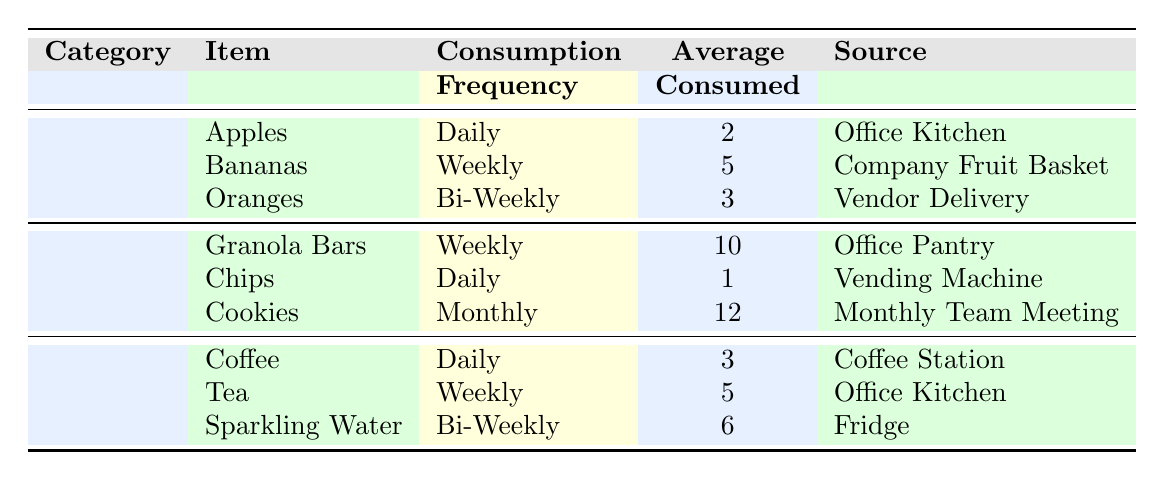What is the average consumption of Coffee? The average consumption of Coffee is listed in the table under the Drinks category. It states that the average consumed is 3.
Answer: 3 How often are Granola Bars consumed? The consumption frequency of Granola Bars is specified in the table as Weekly.
Answer: Weekly Is the consumption of Chips higher than that of Cookies? From the table, Chips are consumed Daily at an average of 1, while Cookies are consumed Monthly at an average of 12. 1 is lesser than 12, so Chips have lower consumption than Cookies.
Answer: No What is the total average consumption of Fruits? To find the total average consumption of Fruits, we will sum the average consumed values: 2 (Apples) + 5 (Bananas) + 3 (Oranges) = 10.
Answer: 10 Which item has the highest average consumption and what is its frequency? In the Snacks category, Granola Bars have the highest average consumption at 10, consumed Weekly.
Answer: Granola Bars, Weekly How many items fall under the Snacks category? The table shows there are three items listed under the Snacks category: Granola Bars, Chips, and Cookies. Therefore, the total count is three.
Answer: 3 Are all the Drinks daily consumables? In the Drinks category, Coffee is consumed Daily, Tea Weekly, and Sparkling Water Bi-Weekly. Not all drinks are consumed daily.
Answer: No What is the average consumption of items in the Fruits category? To find the average consumption in the Fruits category: (2 + 5 + 3) / 3 = 10 / 3 = approximately 3.33.
Answer: 3.33 Which source is used for Oranges? The source of Oranges is listed in the table as Vendor Delivery.
Answer: Vendor Delivery 